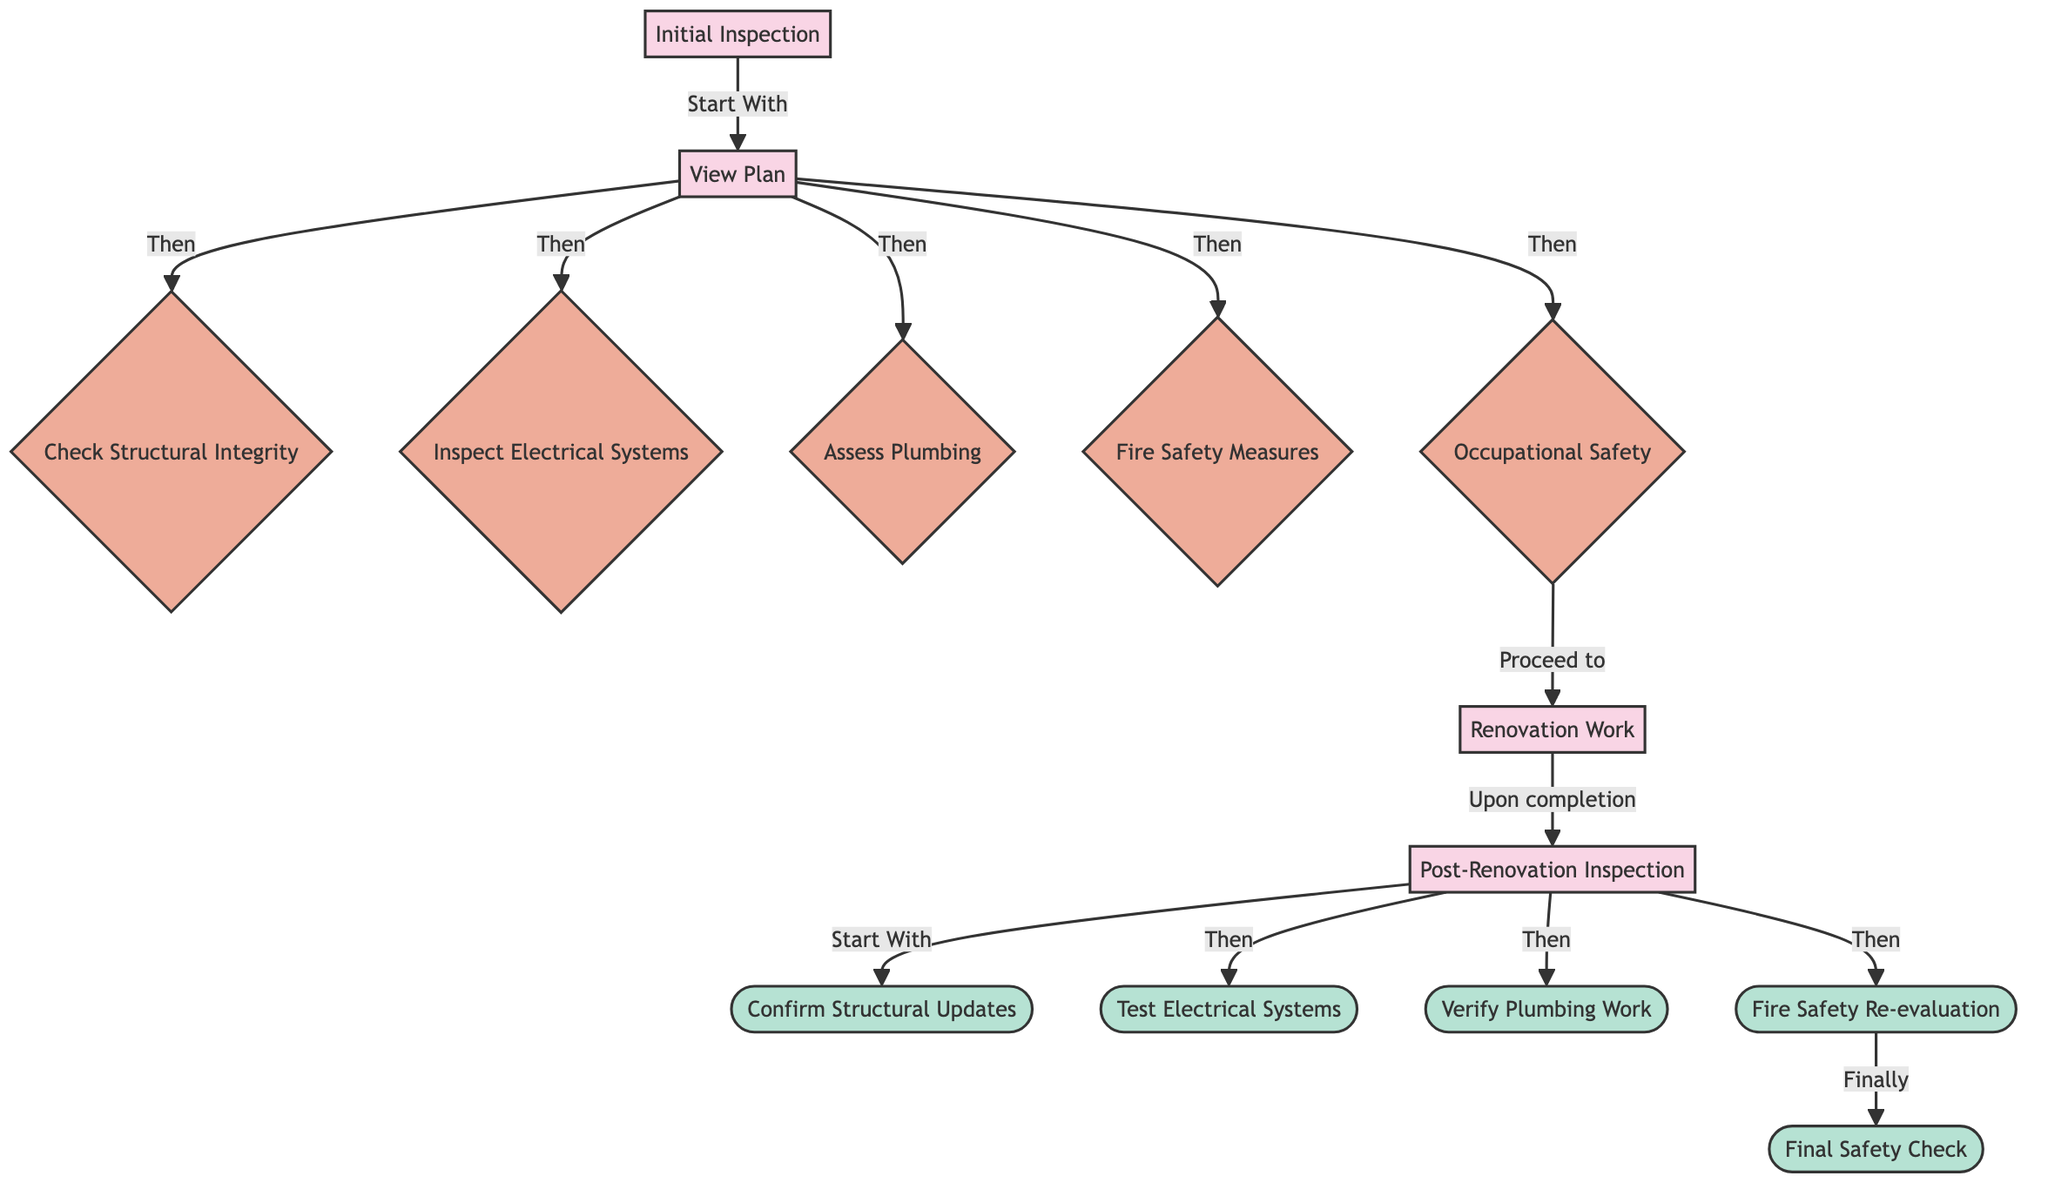What is the first step in the inspection process? The inspection process begins with the "Initial Inspection" node, which is the first step indicated in the diagram.
Answer: Initial Inspection How many checks are performed after the renovation work? In the post-renovation inspection stage, there are four checks: Confirm Structural Updates, Test Electrical Systems, Verify Plumbing Work, and Fire Safety Re-evaluation. Thus, there are a total of four checks indicated.
Answer: 4 What comes after "Occupational Safety"? After "Occupational Safety", the diagram indicates a path leading to "Renovation Work". The process continues directly to this next stage.
Answer: Renovation Work Which safety measure is checked last in the post-renovation inspection? The last step indicated in the post-renovation inspection is "Final Safety Check", which follows "Fire Safety Re-evaluation".
Answer: Final Safety Check How many total nodes are there in the diagram? By counting all the nodes in the diagram, there are a total of 14 nodes present including processes, checks, and verifications.
Answer: 14 Which node connects the initial inspection to the checks? The node "View Plan" connects the initial inspection to the checks, as it is the intermediary step directing the flow to multiple checks following it.
Answer: View Plan What is the relationship between "Renovation Work" and "Post-Renovation Inspection"? The relationship is sequential: "Renovation Work" must be completed before moving to "Post-Renovation Inspection", as indicated by the directed flow from one step to the next.
Answer: sequential What is the purpose of the "Test Electrical Systems" check? The purpose of the "Test Electrical Systems" check is to ensure that all electrical systems are functioning correctly after the renovation, which is a critical safety verification component.
Answer: verify functionality Which check is performed right before the "Final Safety Check"? The "Fire Safety Re-evaluation" check is performed immediately before the "Final Safety Check", as shown in the diagram indicating the flow of checks.
Answer: Fire Safety Re-evaluation 